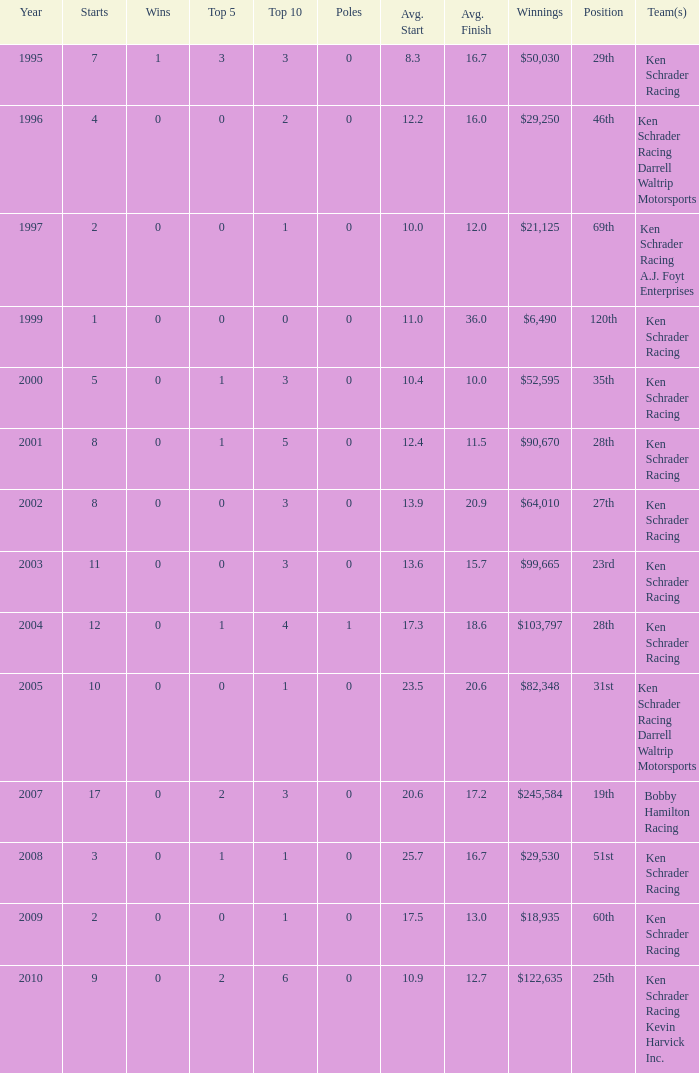How many top 10s belong to the team with a start of 7 and an average finish less than 16.7? 0.0. 